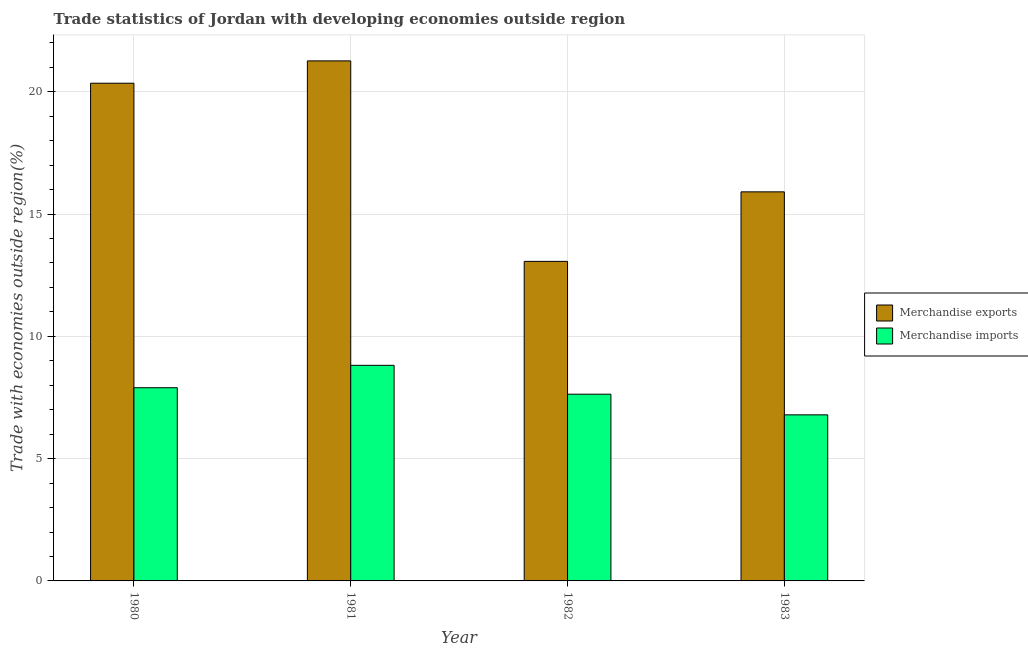How many different coloured bars are there?
Ensure brevity in your answer.  2. How many groups of bars are there?
Keep it short and to the point. 4. How many bars are there on the 2nd tick from the left?
Ensure brevity in your answer.  2. How many bars are there on the 3rd tick from the right?
Offer a terse response. 2. In how many cases, is the number of bars for a given year not equal to the number of legend labels?
Your answer should be very brief. 0. What is the merchandise exports in 1983?
Ensure brevity in your answer.  15.91. Across all years, what is the maximum merchandise imports?
Provide a succinct answer. 8.81. Across all years, what is the minimum merchandise imports?
Offer a terse response. 6.79. What is the total merchandise exports in the graph?
Your answer should be compact. 70.58. What is the difference between the merchandise imports in 1981 and that in 1982?
Your response must be concise. 1.18. What is the difference between the merchandise exports in 1980 and the merchandise imports in 1983?
Give a very brief answer. 4.44. What is the average merchandise exports per year?
Ensure brevity in your answer.  17.65. What is the ratio of the merchandise exports in 1981 to that in 1983?
Your answer should be compact. 1.34. Is the merchandise imports in 1980 less than that in 1983?
Offer a terse response. No. Is the difference between the merchandise imports in 1980 and 1982 greater than the difference between the merchandise exports in 1980 and 1982?
Ensure brevity in your answer.  No. What is the difference between the highest and the second highest merchandise exports?
Provide a succinct answer. 0.91. What is the difference between the highest and the lowest merchandise imports?
Offer a terse response. 2.02. Is the sum of the merchandise imports in 1981 and 1982 greater than the maximum merchandise exports across all years?
Your response must be concise. Yes. What does the 1st bar from the left in 1982 represents?
Ensure brevity in your answer.  Merchandise exports. What does the 2nd bar from the right in 1983 represents?
Offer a very short reply. Merchandise exports. How many bars are there?
Provide a short and direct response. 8. Are all the bars in the graph horizontal?
Your answer should be compact. No. How many years are there in the graph?
Ensure brevity in your answer.  4. Are the values on the major ticks of Y-axis written in scientific E-notation?
Provide a succinct answer. No. Does the graph contain grids?
Make the answer very short. Yes. What is the title of the graph?
Provide a succinct answer. Trade statistics of Jordan with developing economies outside region. Does "Secondary Education" appear as one of the legend labels in the graph?
Keep it short and to the point. No. What is the label or title of the X-axis?
Provide a succinct answer. Year. What is the label or title of the Y-axis?
Provide a succinct answer. Trade with economies outside region(%). What is the Trade with economies outside region(%) in Merchandise exports in 1980?
Your answer should be very brief. 20.35. What is the Trade with economies outside region(%) of Merchandise imports in 1980?
Offer a very short reply. 7.9. What is the Trade with economies outside region(%) in Merchandise exports in 1981?
Make the answer very short. 21.26. What is the Trade with economies outside region(%) of Merchandise imports in 1981?
Keep it short and to the point. 8.81. What is the Trade with economies outside region(%) of Merchandise exports in 1982?
Offer a very short reply. 13.06. What is the Trade with economies outside region(%) of Merchandise imports in 1982?
Provide a succinct answer. 7.63. What is the Trade with economies outside region(%) of Merchandise exports in 1983?
Your answer should be very brief. 15.91. What is the Trade with economies outside region(%) of Merchandise imports in 1983?
Make the answer very short. 6.79. Across all years, what is the maximum Trade with economies outside region(%) of Merchandise exports?
Provide a short and direct response. 21.26. Across all years, what is the maximum Trade with economies outside region(%) in Merchandise imports?
Your answer should be very brief. 8.81. Across all years, what is the minimum Trade with economies outside region(%) of Merchandise exports?
Keep it short and to the point. 13.06. Across all years, what is the minimum Trade with economies outside region(%) of Merchandise imports?
Your answer should be compact. 6.79. What is the total Trade with economies outside region(%) of Merchandise exports in the graph?
Make the answer very short. 70.58. What is the total Trade with economies outside region(%) of Merchandise imports in the graph?
Ensure brevity in your answer.  31.14. What is the difference between the Trade with economies outside region(%) of Merchandise exports in 1980 and that in 1981?
Ensure brevity in your answer.  -0.91. What is the difference between the Trade with economies outside region(%) in Merchandise imports in 1980 and that in 1981?
Ensure brevity in your answer.  -0.92. What is the difference between the Trade with economies outside region(%) in Merchandise exports in 1980 and that in 1982?
Keep it short and to the point. 7.28. What is the difference between the Trade with economies outside region(%) of Merchandise imports in 1980 and that in 1982?
Keep it short and to the point. 0.26. What is the difference between the Trade with economies outside region(%) of Merchandise exports in 1980 and that in 1983?
Your answer should be very brief. 4.44. What is the difference between the Trade with economies outside region(%) in Merchandise imports in 1980 and that in 1983?
Make the answer very short. 1.11. What is the difference between the Trade with economies outside region(%) of Merchandise exports in 1981 and that in 1982?
Your answer should be very brief. 8.2. What is the difference between the Trade with economies outside region(%) of Merchandise imports in 1981 and that in 1982?
Offer a very short reply. 1.18. What is the difference between the Trade with economies outside region(%) in Merchandise exports in 1981 and that in 1983?
Provide a succinct answer. 5.35. What is the difference between the Trade with economies outside region(%) of Merchandise imports in 1981 and that in 1983?
Offer a terse response. 2.02. What is the difference between the Trade with economies outside region(%) of Merchandise exports in 1982 and that in 1983?
Provide a short and direct response. -2.84. What is the difference between the Trade with economies outside region(%) in Merchandise imports in 1982 and that in 1983?
Make the answer very short. 0.84. What is the difference between the Trade with economies outside region(%) of Merchandise exports in 1980 and the Trade with economies outside region(%) of Merchandise imports in 1981?
Your answer should be very brief. 11.53. What is the difference between the Trade with economies outside region(%) in Merchandise exports in 1980 and the Trade with economies outside region(%) in Merchandise imports in 1982?
Offer a terse response. 12.71. What is the difference between the Trade with economies outside region(%) of Merchandise exports in 1980 and the Trade with economies outside region(%) of Merchandise imports in 1983?
Offer a terse response. 13.56. What is the difference between the Trade with economies outside region(%) in Merchandise exports in 1981 and the Trade with economies outside region(%) in Merchandise imports in 1982?
Your answer should be very brief. 13.63. What is the difference between the Trade with economies outside region(%) of Merchandise exports in 1981 and the Trade with economies outside region(%) of Merchandise imports in 1983?
Provide a short and direct response. 14.47. What is the difference between the Trade with economies outside region(%) of Merchandise exports in 1982 and the Trade with economies outside region(%) of Merchandise imports in 1983?
Offer a terse response. 6.27. What is the average Trade with economies outside region(%) of Merchandise exports per year?
Give a very brief answer. 17.65. What is the average Trade with economies outside region(%) in Merchandise imports per year?
Give a very brief answer. 7.78. In the year 1980, what is the difference between the Trade with economies outside region(%) in Merchandise exports and Trade with economies outside region(%) in Merchandise imports?
Provide a succinct answer. 12.45. In the year 1981, what is the difference between the Trade with economies outside region(%) in Merchandise exports and Trade with economies outside region(%) in Merchandise imports?
Offer a terse response. 12.45. In the year 1982, what is the difference between the Trade with economies outside region(%) of Merchandise exports and Trade with economies outside region(%) of Merchandise imports?
Give a very brief answer. 5.43. In the year 1983, what is the difference between the Trade with economies outside region(%) in Merchandise exports and Trade with economies outside region(%) in Merchandise imports?
Keep it short and to the point. 9.12. What is the ratio of the Trade with economies outside region(%) of Merchandise exports in 1980 to that in 1981?
Provide a succinct answer. 0.96. What is the ratio of the Trade with economies outside region(%) of Merchandise imports in 1980 to that in 1981?
Make the answer very short. 0.9. What is the ratio of the Trade with economies outside region(%) in Merchandise exports in 1980 to that in 1982?
Offer a very short reply. 1.56. What is the ratio of the Trade with economies outside region(%) in Merchandise imports in 1980 to that in 1982?
Your answer should be very brief. 1.03. What is the ratio of the Trade with economies outside region(%) of Merchandise exports in 1980 to that in 1983?
Offer a very short reply. 1.28. What is the ratio of the Trade with economies outside region(%) in Merchandise imports in 1980 to that in 1983?
Keep it short and to the point. 1.16. What is the ratio of the Trade with economies outside region(%) in Merchandise exports in 1981 to that in 1982?
Give a very brief answer. 1.63. What is the ratio of the Trade with economies outside region(%) of Merchandise imports in 1981 to that in 1982?
Give a very brief answer. 1.15. What is the ratio of the Trade with economies outside region(%) of Merchandise exports in 1981 to that in 1983?
Provide a succinct answer. 1.34. What is the ratio of the Trade with economies outside region(%) in Merchandise imports in 1981 to that in 1983?
Provide a succinct answer. 1.3. What is the ratio of the Trade with economies outside region(%) of Merchandise exports in 1982 to that in 1983?
Your response must be concise. 0.82. What is the ratio of the Trade with economies outside region(%) in Merchandise imports in 1982 to that in 1983?
Your response must be concise. 1.12. What is the difference between the highest and the second highest Trade with economies outside region(%) of Merchandise exports?
Your answer should be compact. 0.91. What is the difference between the highest and the second highest Trade with economies outside region(%) of Merchandise imports?
Your answer should be compact. 0.92. What is the difference between the highest and the lowest Trade with economies outside region(%) of Merchandise exports?
Offer a terse response. 8.2. What is the difference between the highest and the lowest Trade with economies outside region(%) in Merchandise imports?
Provide a short and direct response. 2.02. 